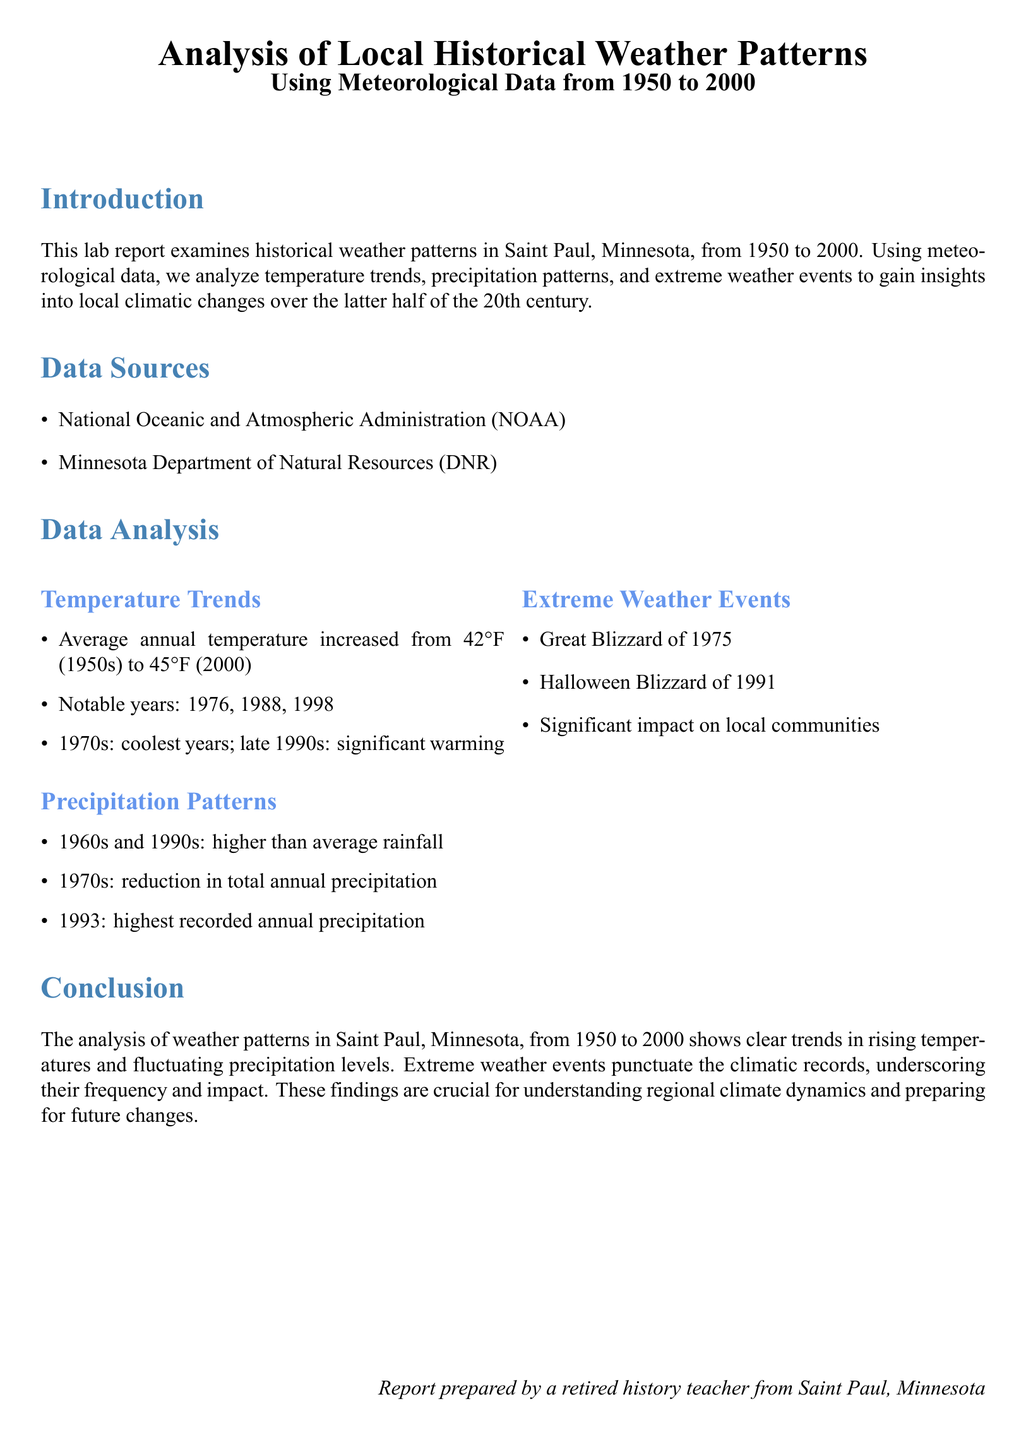What was the average annual temperature in the 1950s? The average annual temperature in the 1950s was 42°F.
Answer: 42°F What year had the highest recorded annual precipitation? The document states that 1993 had the highest recorded annual precipitation.
Answer: 1993 What significant weather event occurred in 1975? The Great Blizzard of 1975 is mentioned as a significant weather event.
Answer: Great Blizzard of 1975 What was the average annual temperature in 2000? The average annual temperature in 2000 increased to 45°F.
Answer: 45°F Which decades experienced higher than average rainfall? The 1960s and 1990s are noted for higher than average rainfall.
Answer: 1960s and 1990s What notable years show significant warming trends? The document mentions the years 1976, 1988, and 1998 as notable in the context of warming trends.
Answer: 1976, 1988, 1998 What conclusion can be drawn from the analysis? The conclusion states that there is a clear trend in rising temperatures and fluctuating precipitation levels.
Answer: Rising temperatures and fluctuating precipitation levels What type of document is this? This document is a lab report.
Answer: Lab report 